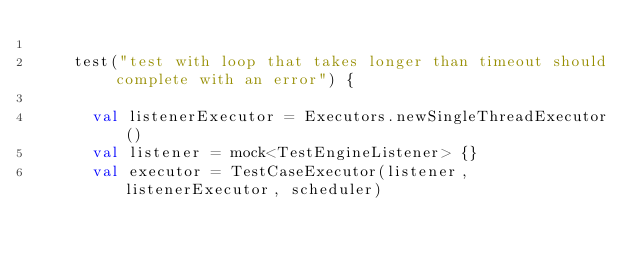<code> <loc_0><loc_0><loc_500><loc_500><_Kotlin_>
    test("test with loop that takes longer than timeout should complete with an error") {

      val listenerExecutor = Executors.newSingleThreadExecutor()
      val listener = mock<TestEngineListener> {}
      val executor = TestCaseExecutor(listener, listenerExecutor, scheduler)
</code> 